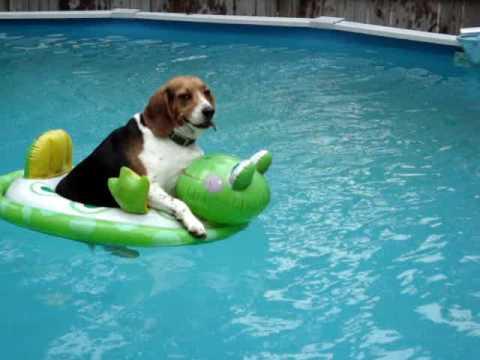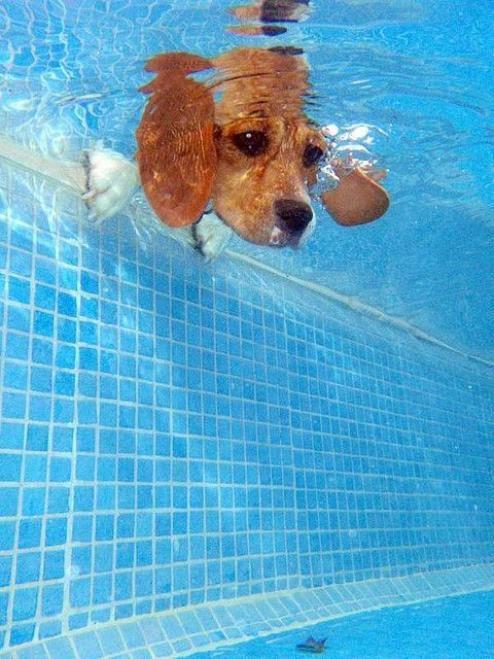The first image is the image on the left, the second image is the image on the right. Evaluate the accuracy of this statement regarding the images: "a dog is swimming with a toy in its mouth". Is it true? Answer yes or no. No. The first image is the image on the left, the second image is the image on the right. Given the left and right images, does the statement "The dog on the right image has its head under water." hold true? Answer yes or no. Yes. 